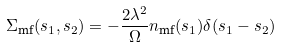Convert formula to latex. <formula><loc_0><loc_0><loc_500><loc_500>\Sigma _ { \text {mf} } ( s _ { 1 } , s _ { 2 } ) & = - \frac { 2 \lambda ^ { 2 } } { \Omega } n _ { \text {mf} } ( s _ { 1 } ) \delta ( s _ { 1 } - s _ { 2 } )</formula> 